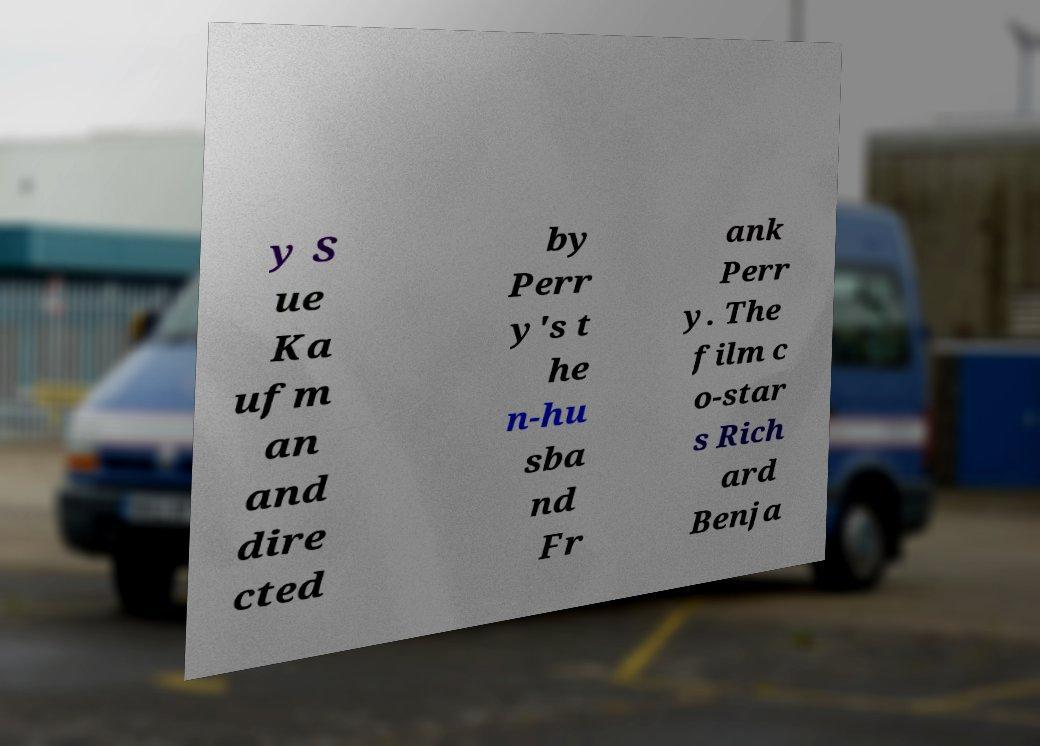Can you read and provide the text displayed in the image?This photo seems to have some interesting text. Can you extract and type it out for me? y S ue Ka ufm an and dire cted by Perr y's t he n-hu sba nd Fr ank Perr y. The film c o-star s Rich ard Benja 